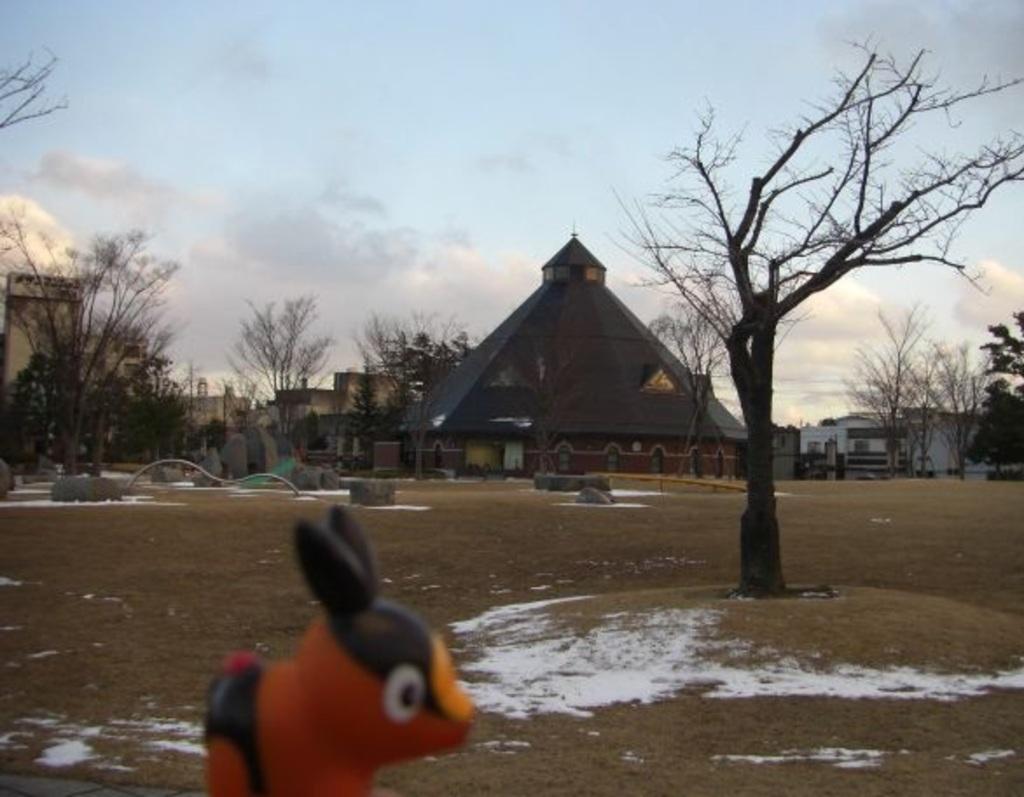In one or two sentences, can you explain what this image depicts? In this image we can see a few buildings, there are some trees, stones and a toy, in the background, we can see the sky with clouds. 